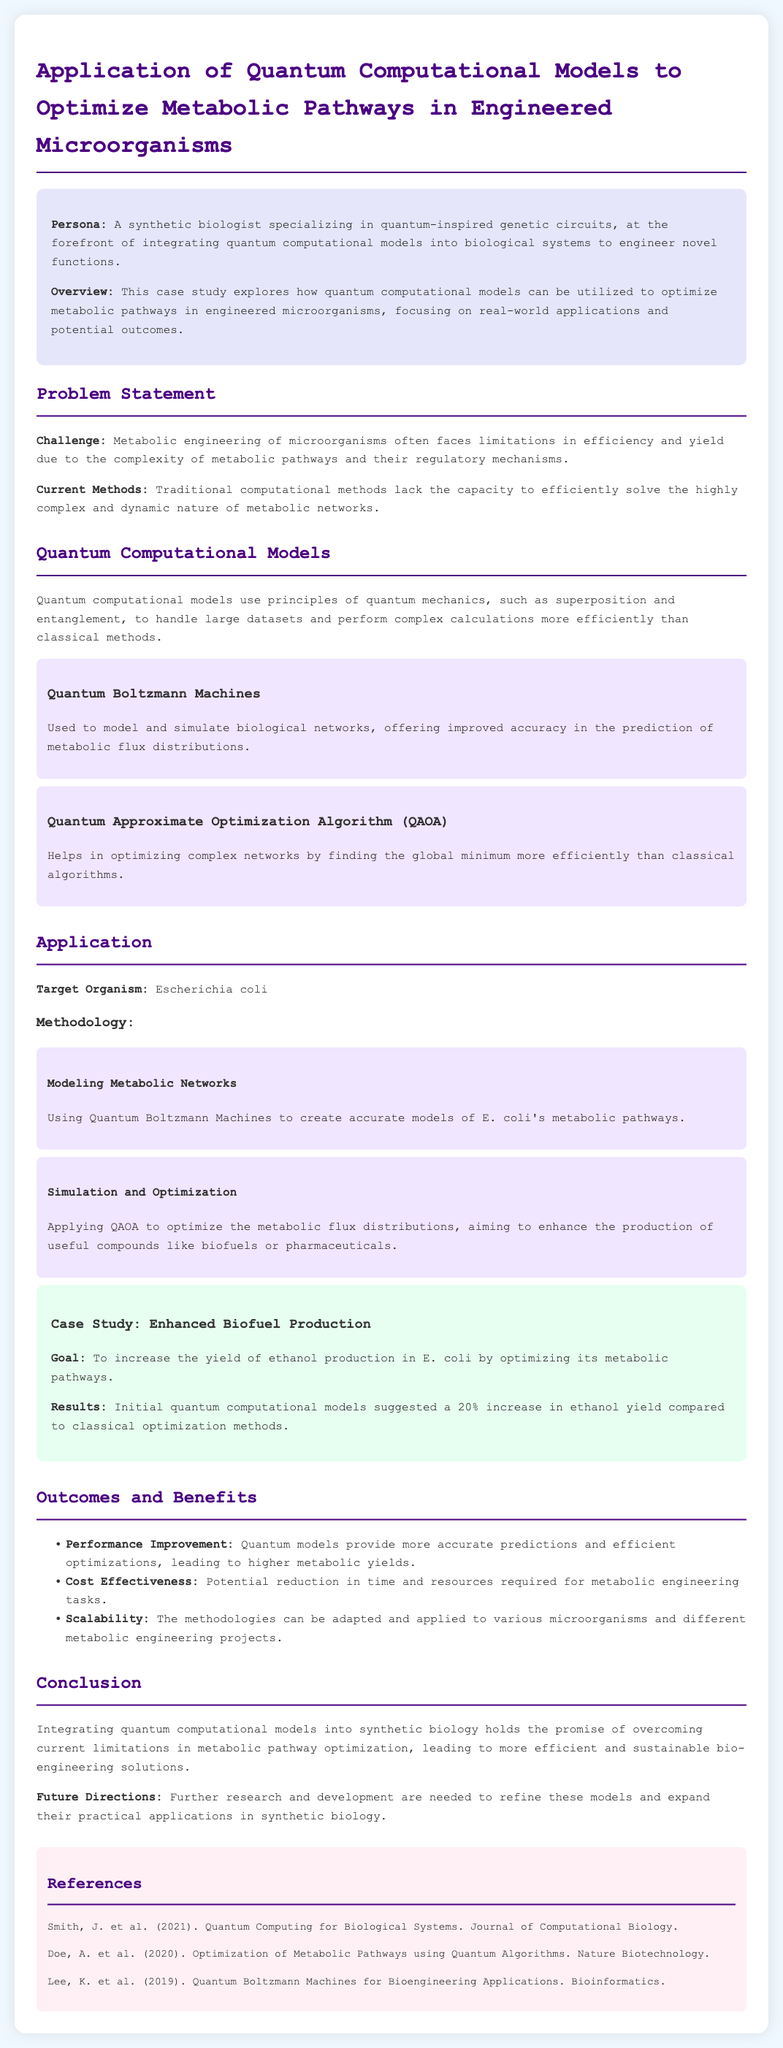What is the main challenge faced in metabolic engineering? The main challenge in metabolic engineering is the complexity of metabolic pathways and their regulatory mechanisms.
Answer: Complexity of metabolic pathways Which quantum computational model is used to simulate biological networks? The document mentions Quantum Boltzmann Machines as a model used to simulate biological networks.
Answer: Quantum Boltzmann Machines What organism is targeted for optimization in this case study? The target organism for optimization discussed in the case study is Escherichia coli.
Answer: Escherichia coli By what percentage did quantum computational models improve ethanol yield? The document states that quantum computational models suggested a 20% increase in ethanol yield compared to classical methods.
Answer: 20% What is one benefit of using quantum models mentioned in the document? The document states that one benefit of quantum models is that they provide more accurate predictions and efficient optimizations.
Answer: More accurate predictions What methodology is applied for optimizing metabolic flux distributions? The Quantum Approximate Optimization Algorithm (QAOA) is the methodology applied for optimizing metabolic flux distributions.
Answer: QAOA What are the future directions suggested in the case study? The document suggests that further research and development are needed to refine quantum models and expand their applications.
Answer: Further research and development Which publication discusses quantum computing for biological systems? The reference to the publication by Smith, J. et al. (2021) discusses quantum computing for biological systems.
Answer: Smith, J. et al. (2021) 